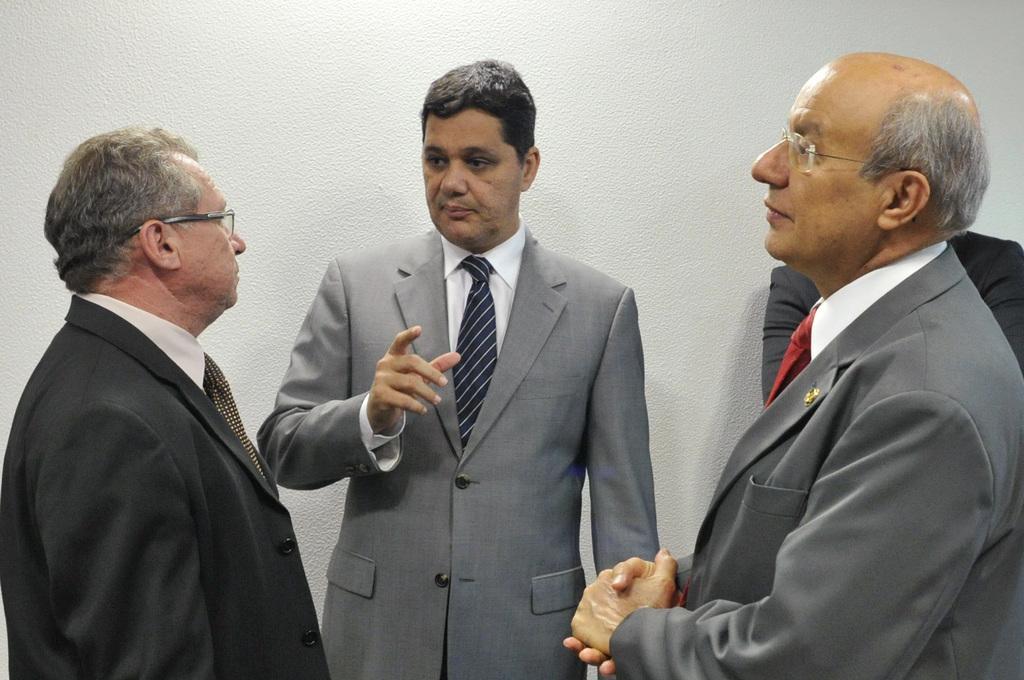Describe this image in one or two sentences. In this picture we can see there are four people standing on the floor and behind the people there is a white wall. 